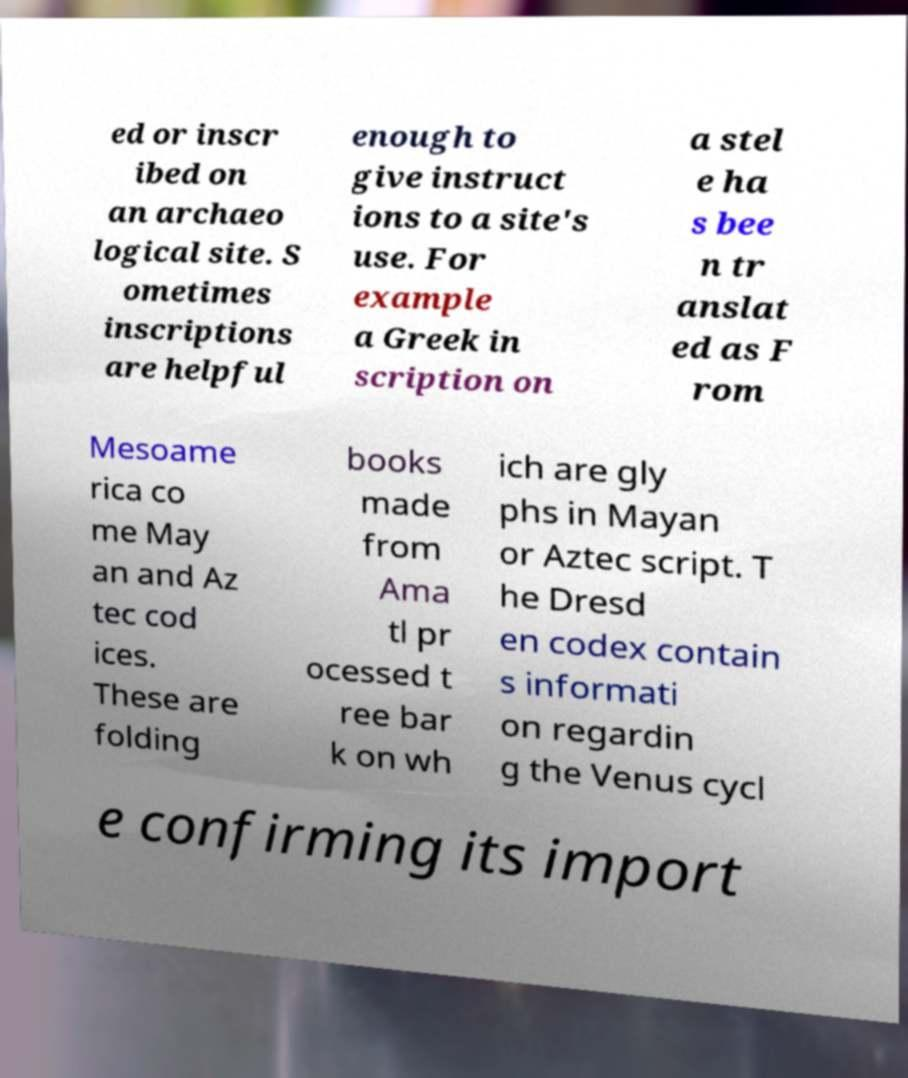There's text embedded in this image that I need extracted. Can you transcribe it verbatim? ed or inscr ibed on an archaeo logical site. S ometimes inscriptions are helpful enough to give instruct ions to a site's use. For example a Greek in scription on a stel e ha s bee n tr anslat ed as F rom Mesoame rica co me May an and Az tec cod ices. These are folding books made from Ama tl pr ocessed t ree bar k on wh ich are gly phs in Mayan or Aztec script. T he Dresd en codex contain s informati on regardin g the Venus cycl e confirming its import 